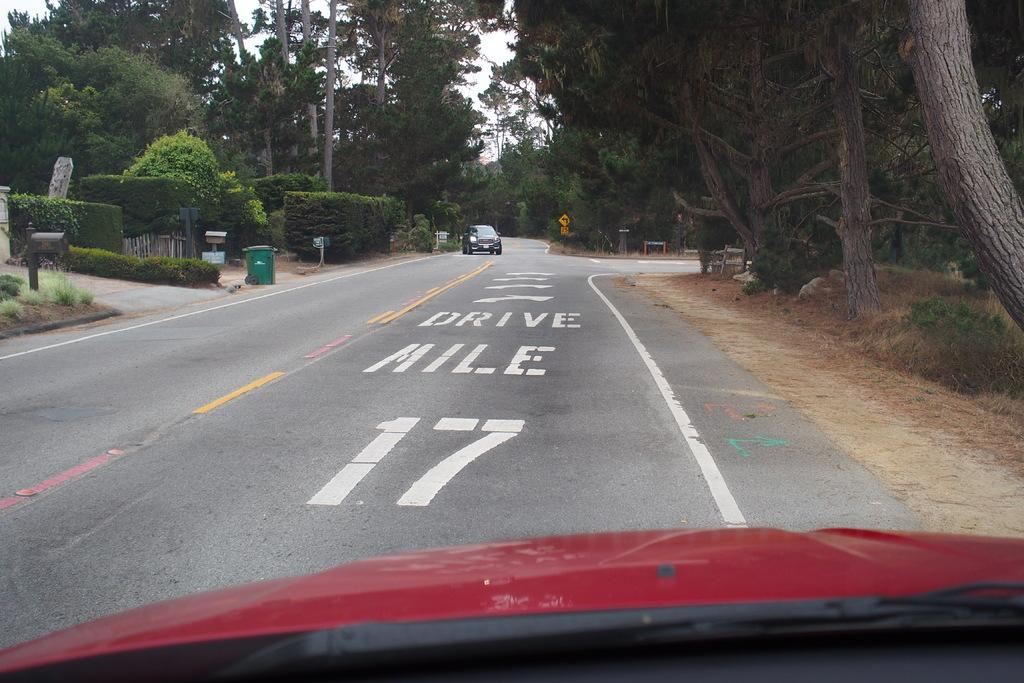What type of vegetation can be seen in the image? There are trees and plants in the image. What object is used for waste disposal in the image? There is a dustbin in the image. What type of vehicle is present in the image? There is a car in the image. What can be seen on the road in the image? There is some text on the road in the image. What type of food is being played by the band in the image? There is no band present in the image, so it is not possible to determine what type of food they might be playing. 